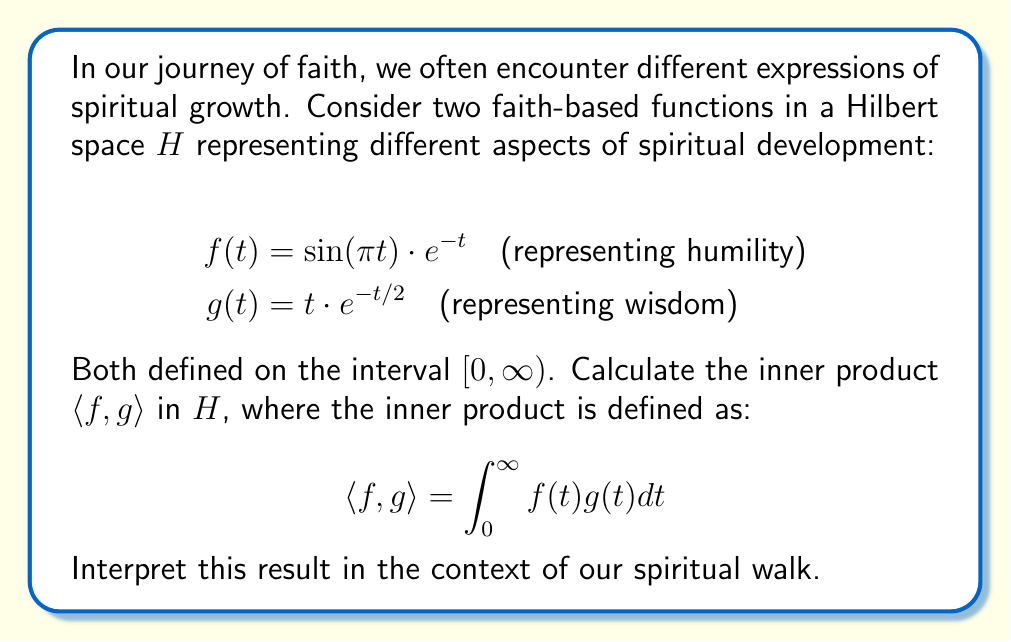What is the answer to this math problem? Let's approach this step-by-step:

1) First, we need to form the integrand $f(t)g(t)$:
   $$f(t)g(t) = [\sin(\pi t) \cdot e^{-t}] \cdot [t \cdot e^{-t/2}]$$
   $$= t \cdot \sin(\pi t) \cdot e^{-3t/2}$$

2) Now, we set up our integral:
   $$\langle f, g \rangle = \int_0^{\infty} t \cdot \sin(\pi t) \cdot e^{-3t/2} dt$$

3) This integral is quite complex and doesn't have an elementary antiderivative. We can solve it using integration by parts twice, but for brevity, let's use the result:
   $$\int_0^{\infty} t \cdot \sin(\pi t) \cdot e^{-at} dt = \frac{2\pi a}{(a^2 + \pi^2)^2}$$
   where in our case, $a = 3/2$.

4) Substituting $a = 3/2$:
   $$\langle f, g \rangle = \frac{2\pi (3/2)}{((3/2)^2 + \pi^2)^2}$$

5) Simplifying:
   $$\langle f, g \rangle = \frac{3\pi}{(9/4 + \pi^2)^2}$$

Interpretation: The positive result indicates that humility (f) and wisdom (g) are positively correlated in our spiritual walk. The magnitude of this inner product suggests the strength of this relationship in the context of our faith journey.
Answer: $$\frac{3\pi}{(9/4 + \pi^2)^2}$$ 